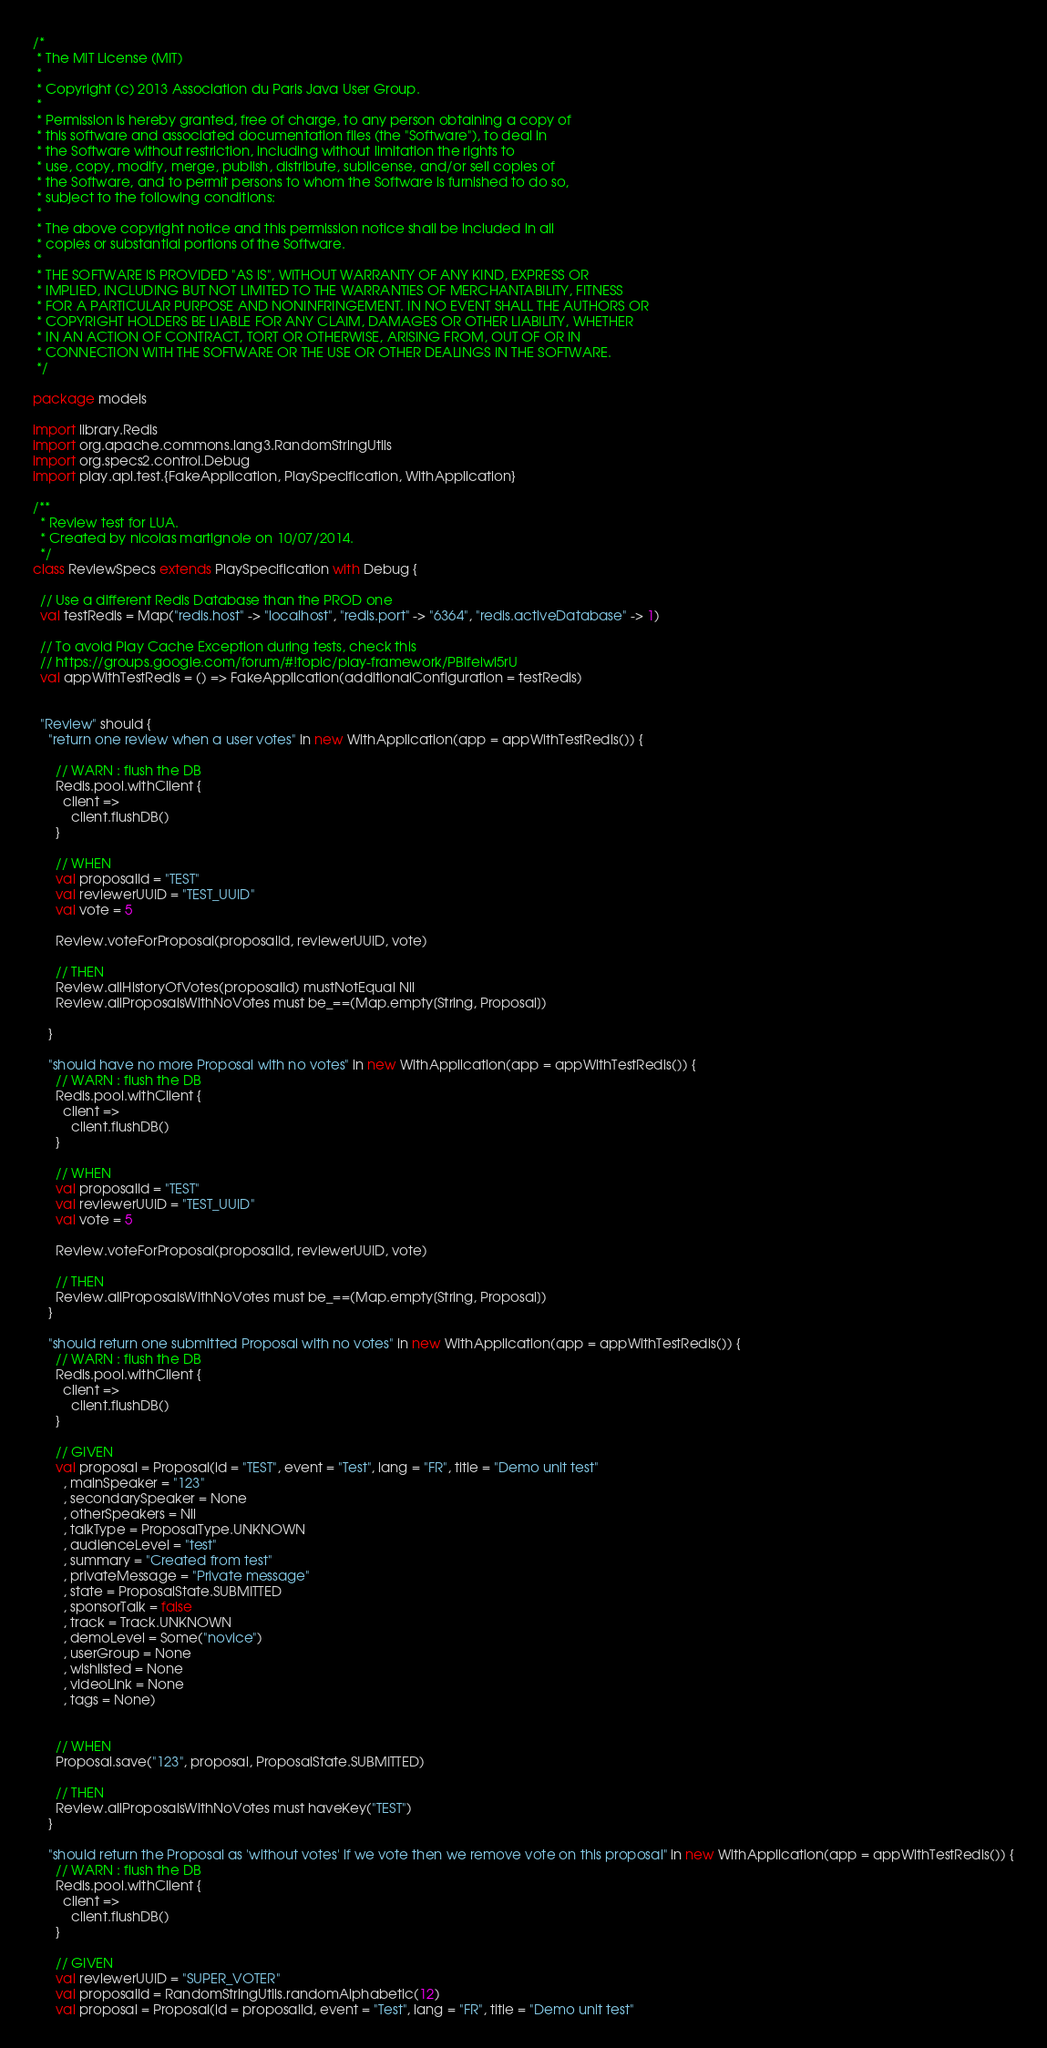<code> <loc_0><loc_0><loc_500><loc_500><_Scala_>/*
 * The MIT License (MIT)
 *
 * Copyright (c) 2013 Association du Paris Java User Group.
 *
 * Permission is hereby granted, free of charge, to any person obtaining a copy of
 * this software and associated documentation files (the "Software"), to deal in
 * the Software without restriction, including without limitation the rights to
 * use, copy, modify, merge, publish, distribute, sublicense, and/or sell copies of
 * the Software, and to permit persons to whom the Software is furnished to do so,
 * subject to the following conditions:
 *
 * The above copyright notice and this permission notice shall be included in all
 * copies or substantial portions of the Software.
 *
 * THE SOFTWARE IS PROVIDED "AS IS", WITHOUT WARRANTY OF ANY KIND, EXPRESS OR
 * IMPLIED, INCLUDING BUT NOT LIMITED TO THE WARRANTIES OF MERCHANTABILITY, FITNESS
 * FOR A PARTICULAR PURPOSE AND NONINFRINGEMENT. IN NO EVENT SHALL THE AUTHORS OR
 * COPYRIGHT HOLDERS BE LIABLE FOR ANY CLAIM, DAMAGES OR OTHER LIABILITY, WHETHER
 * IN AN ACTION OF CONTRACT, TORT OR OTHERWISE, ARISING FROM, OUT OF OR IN
 * CONNECTION WITH THE SOFTWARE OR THE USE OR OTHER DEALINGS IN THE SOFTWARE.
 */

package models

import library.Redis
import org.apache.commons.lang3.RandomStringUtils
import org.specs2.control.Debug
import play.api.test.{FakeApplication, PlaySpecification, WithApplication}

/**
  * Review test for LUA.
  * Created by nicolas martignole on 10/07/2014.
  */
class ReviewSpecs extends PlaySpecification with Debug {

  // Use a different Redis Database than the PROD one
  val testRedis = Map("redis.host" -> "localhost", "redis.port" -> "6364", "redis.activeDatabase" -> 1)

  // To avoid Play Cache Exception during tests, check this
  // https://groups.google.com/forum/#!topic/play-framework/PBIfeiwl5rU
  val appWithTestRedis = () => FakeApplication(additionalConfiguration = testRedis)


  "Review" should {
    "return one review when a user votes" in new WithApplication(app = appWithTestRedis()) {

      // WARN : flush the DB
      Redis.pool.withClient {
        client =>
          client.flushDB()
      }

      // WHEN
      val proposalId = "TEST"
      val reviewerUUID = "TEST_UUID"
      val vote = 5

      Review.voteForProposal(proposalId, reviewerUUID, vote)

      // THEN
      Review.allHistoryOfVotes(proposalId) mustNotEqual Nil
      Review.allProposalsWithNoVotes must be_==(Map.empty[String, Proposal])

    }

    "should have no more Proposal with no votes" in new WithApplication(app = appWithTestRedis()) {
      // WARN : flush the DB
      Redis.pool.withClient {
        client =>
          client.flushDB()
      }

      // WHEN
      val proposalId = "TEST"
      val reviewerUUID = "TEST_UUID"
      val vote = 5

      Review.voteForProposal(proposalId, reviewerUUID, vote)

      // THEN
      Review.allProposalsWithNoVotes must be_==(Map.empty[String, Proposal])
    }

    "should return one submitted Proposal with no votes" in new WithApplication(app = appWithTestRedis()) {
      // WARN : flush the DB
      Redis.pool.withClient {
        client =>
          client.flushDB()
      }

      // GIVEN
      val proposal = Proposal(id = "TEST", event = "Test", lang = "FR", title = "Demo unit test"
        , mainSpeaker = "123"
        , secondarySpeaker = None
        , otherSpeakers = Nil
        , talkType = ProposalType.UNKNOWN
        , audienceLevel = "test"
        , summary = "Created from test"
        , privateMessage = "Private message"
        , state = ProposalState.SUBMITTED
        , sponsorTalk = false
        , track = Track.UNKNOWN
        , demoLevel = Some("novice")
        , userGroup = None
        , wishlisted = None
        , videoLink = None
        , tags = None)


      // WHEN
      Proposal.save("123", proposal, ProposalState.SUBMITTED)

      // THEN
      Review.allProposalsWithNoVotes must haveKey("TEST")
    }

    "should return the Proposal as 'without votes' if we vote then we remove vote on this proposal" in new WithApplication(app = appWithTestRedis()) {
      // WARN : flush the DB
      Redis.pool.withClient {
        client =>
          client.flushDB()
      }

      // GIVEN
      val reviewerUUID = "SUPER_VOTER"
      val proposalId = RandomStringUtils.randomAlphabetic(12)
      val proposal = Proposal(id = proposalId, event = "Test", lang = "FR", title = "Demo unit test"</code> 